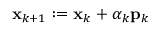<formula> <loc_0><loc_0><loc_500><loc_500>x _ { k + 1 } \colon = x _ { k } + \alpha _ { k } p _ { k }</formula> 